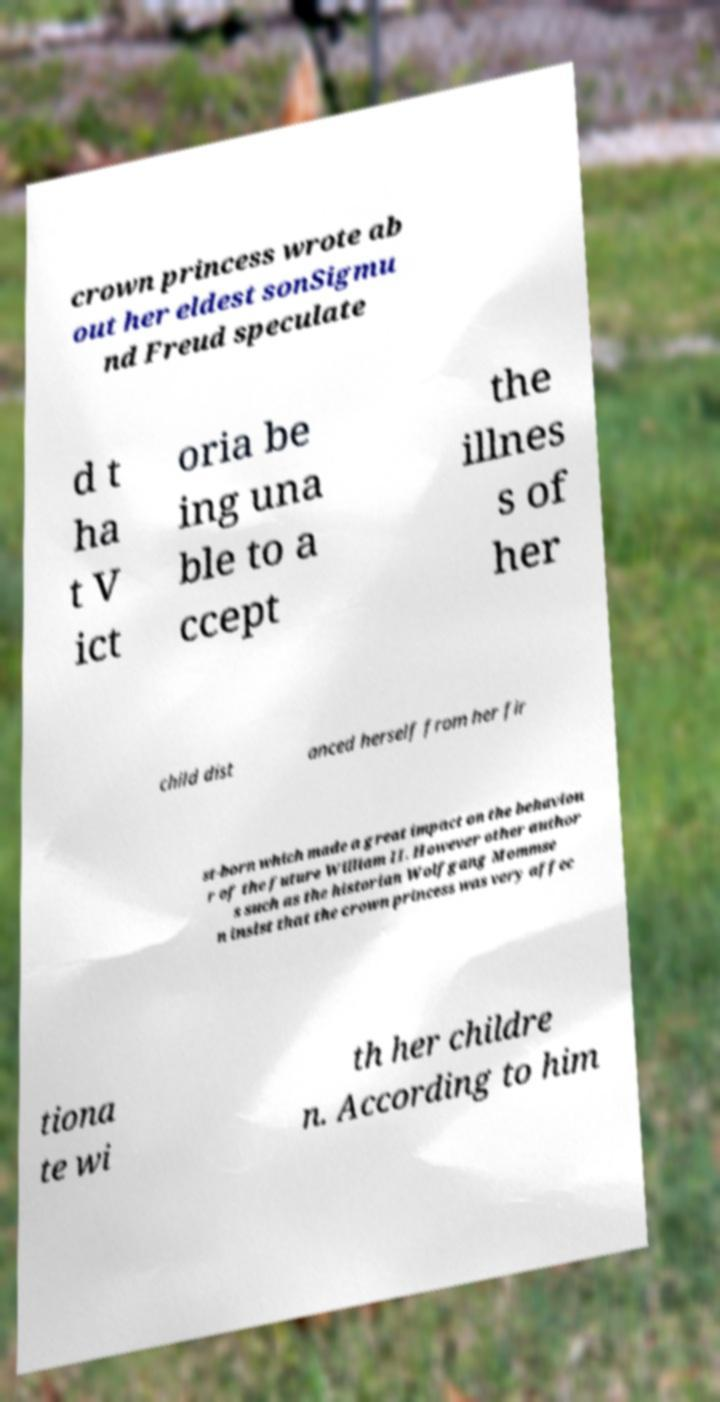Could you assist in decoding the text presented in this image and type it out clearly? crown princess wrote ab out her eldest sonSigmu nd Freud speculate d t ha t V ict oria be ing una ble to a ccept the illnes s of her child dist anced herself from her fir st-born which made a great impact on the behaviou r of the future William II. However other author s such as the historian Wolfgang Mommse n insist that the crown princess was very affec tiona te wi th her childre n. According to him 